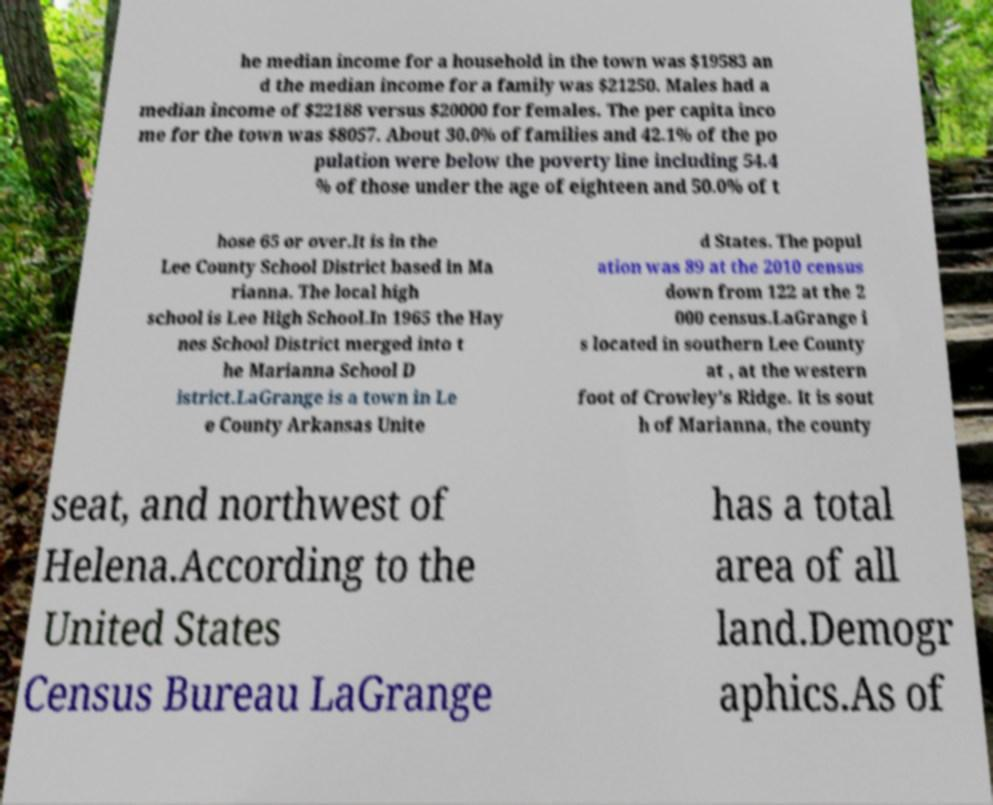Please identify and transcribe the text found in this image. he median income for a household in the town was $19583 an d the median income for a family was $21250. Males had a median income of $22188 versus $20000 for females. The per capita inco me for the town was $8057. About 30.0% of families and 42.1% of the po pulation were below the poverty line including 54.4 % of those under the age of eighteen and 50.0% of t hose 65 or over.It is in the Lee County School District based in Ma rianna. The local high school is Lee High School.In 1965 the Hay nes School District merged into t he Marianna School D istrict.LaGrange is a town in Le e County Arkansas Unite d States. The popul ation was 89 at the 2010 census down from 122 at the 2 000 census.LaGrange i s located in southern Lee County at , at the western foot of Crowley's Ridge. It is sout h of Marianna, the county seat, and northwest of Helena.According to the United States Census Bureau LaGrange has a total area of all land.Demogr aphics.As of 